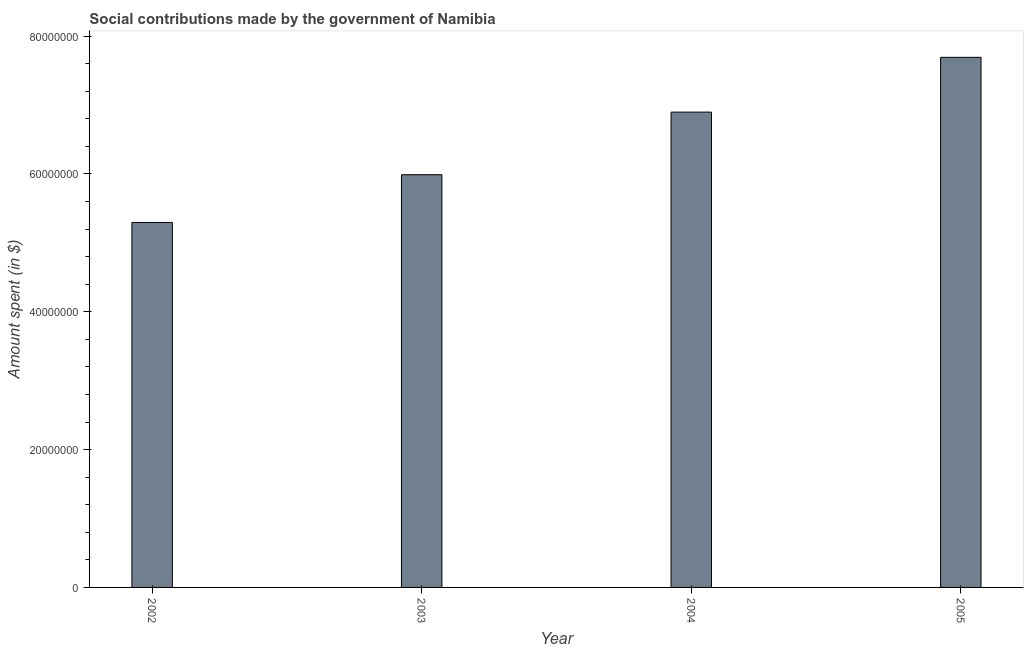Does the graph contain any zero values?
Offer a terse response. No. Does the graph contain grids?
Give a very brief answer. No. What is the title of the graph?
Ensure brevity in your answer.  Social contributions made by the government of Namibia. What is the label or title of the Y-axis?
Your answer should be very brief. Amount spent (in $). What is the amount spent in making social contributions in 2005?
Make the answer very short. 7.69e+07. Across all years, what is the maximum amount spent in making social contributions?
Your answer should be compact. 7.69e+07. Across all years, what is the minimum amount spent in making social contributions?
Give a very brief answer. 5.30e+07. In which year was the amount spent in making social contributions maximum?
Make the answer very short. 2005. What is the sum of the amount spent in making social contributions?
Your answer should be very brief. 2.59e+08. What is the difference between the amount spent in making social contributions in 2003 and 2004?
Ensure brevity in your answer.  -9.08e+06. What is the average amount spent in making social contributions per year?
Offer a very short reply. 6.47e+07. What is the median amount spent in making social contributions?
Make the answer very short. 6.44e+07. Do a majority of the years between 2003 and 2004 (inclusive) have amount spent in making social contributions greater than 52000000 $?
Your response must be concise. Yes. What is the ratio of the amount spent in making social contributions in 2003 to that in 2004?
Keep it short and to the point. 0.87. What is the difference between the highest and the second highest amount spent in making social contributions?
Your response must be concise. 7.95e+06. Is the sum of the amount spent in making social contributions in 2002 and 2004 greater than the maximum amount spent in making social contributions across all years?
Your response must be concise. Yes. What is the difference between the highest and the lowest amount spent in making social contributions?
Provide a short and direct response. 2.40e+07. In how many years, is the amount spent in making social contributions greater than the average amount spent in making social contributions taken over all years?
Your response must be concise. 2. What is the Amount spent (in $) in 2002?
Offer a very short reply. 5.30e+07. What is the Amount spent (in $) of 2003?
Provide a succinct answer. 5.99e+07. What is the Amount spent (in $) in 2004?
Provide a short and direct response. 6.90e+07. What is the Amount spent (in $) in 2005?
Offer a terse response. 7.69e+07. What is the difference between the Amount spent (in $) in 2002 and 2003?
Provide a succinct answer. -6.92e+06. What is the difference between the Amount spent (in $) in 2002 and 2004?
Offer a very short reply. -1.60e+07. What is the difference between the Amount spent (in $) in 2002 and 2005?
Ensure brevity in your answer.  -2.40e+07. What is the difference between the Amount spent (in $) in 2003 and 2004?
Keep it short and to the point. -9.08e+06. What is the difference between the Amount spent (in $) in 2003 and 2005?
Your response must be concise. -1.70e+07. What is the difference between the Amount spent (in $) in 2004 and 2005?
Provide a succinct answer. -7.95e+06. What is the ratio of the Amount spent (in $) in 2002 to that in 2003?
Keep it short and to the point. 0.88. What is the ratio of the Amount spent (in $) in 2002 to that in 2004?
Keep it short and to the point. 0.77. What is the ratio of the Amount spent (in $) in 2002 to that in 2005?
Keep it short and to the point. 0.69. What is the ratio of the Amount spent (in $) in 2003 to that in 2004?
Provide a succinct answer. 0.87. What is the ratio of the Amount spent (in $) in 2003 to that in 2005?
Make the answer very short. 0.78. What is the ratio of the Amount spent (in $) in 2004 to that in 2005?
Offer a very short reply. 0.9. 